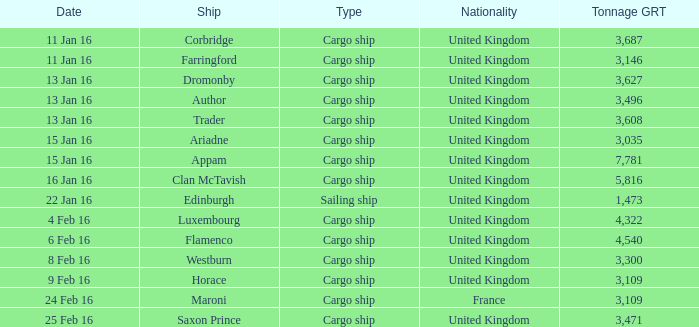What was the largest gross register tonnage (grt) of any ship that was sunk or captured on january 16th? 5816.0. Could you parse the entire table as a dict? {'header': ['Date', 'Ship', 'Type', 'Nationality', 'Tonnage GRT'], 'rows': [['11 Jan 16', 'Corbridge', 'Cargo ship', 'United Kingdom', '3,687'], ['11 Jan 16', 'Farringford', 'Cargo ship', 'United Kingdom', '3,146'], ['13 Jan 16', 'Dromonby', 'Cargo ship', 'United Kingdom', '3,627'], ['13 Jan 16', 'Author', 'Cargo ship', 'United Kingdom', '3,496'], ['13 Jan 16', 'Trader', 'Cargo ship', 'United Kingdom', '3,608'], ['15 Jan 16', 'Ariadne', 'Cargo ship', 'United Kingdom', '3,035'], ['15 Jan 16', 'Appam', 'Cargo ship', 'United Kingdom', '7,781'], ['16 Jan 16', 'Clan McTavish', 'Cargo ship', 'United Kingdom', '5,816'], ['22 Jan 16', 'Edinburgh', 'Sailing ship', 'United Kingdom', '1,473'], ['4 Feb 16', 'Luxembourg', 'Cargo ship', 'United Kingdom', '4,322'], ['6 Feb 16', 'Flamenco', 'Cargo ship', 'United Kingdom', '4,540'], ['8 Feb 16', 'Westburn', 'Cargo ship', 'United Kingdom', '3,300'], ['9 Feb 16', 'Horace', 'Cargo ship', 'United Kingdom', '3,109'], ['24 Feb 16', 'Maroni', 'Cargo ship', 'France', '3,109'], ['25 Feb 16', 'Saxon Prince', 'Cargo ship', 'United Kingdom', '3,471']]} 